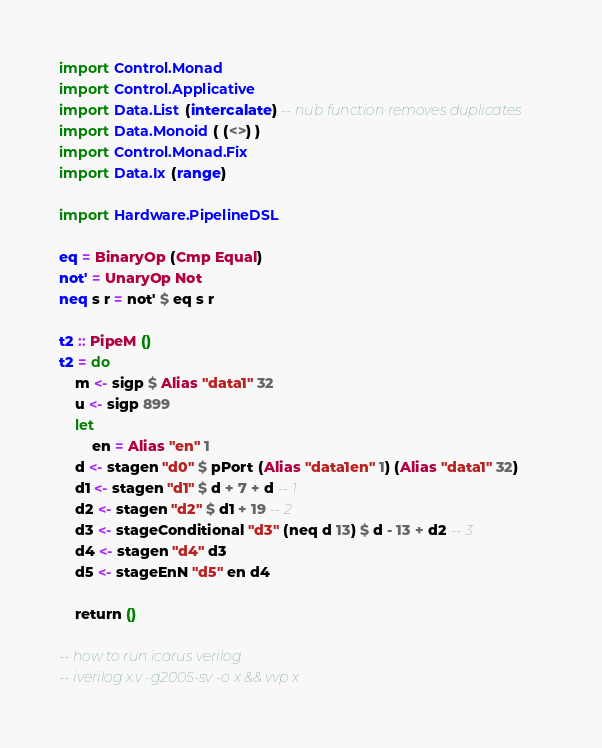<code> <loc_0><loc_0><loc_500><loc_500><_Haskell_>import Control.Monad
import Control.Applicative
import Data.List (intercalate) -- nub function removes duplicates
import Data.Monoid ( (<>) )
import Control.Monad.Fix
import Data.Ix (range)

import Hardware.PipelineDSL

eq = BinaryOp (Cmp Equal)
not' = UnaryOp Not
neq s r = not' $ eq s r

t2 :: PipeM ()
t2 = do
    m <- sigp $ Alias "data1" 32
    u <- sigp 899
    let
        en = Alias "en" 1
    d <- stagen "d0" $ pPort (Alias "data1en" 1) (Alias "data1" 32)
    d1 <- stagen "d1" $ d + 7 + d -- 1
    d2 <- stagen "d2" $ d1 + 19 -- 2
    d3 <- stageConditional "d3" (neq d 13) $ d - 13 + d2 -- 3
    d4 <- stagen "d4" d3
    d5 <- stageEnN "d5" en d4

    return ()

-- how to run icarus verilog
-- iverilog x.v -g2005-sv -o x && vvp x
</code> 